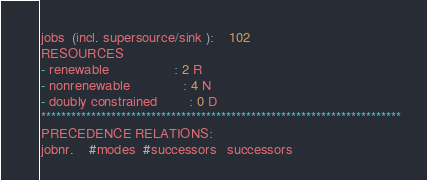<code> <loc_0><loc_0><loc_500><loc_500><_ObjectiveC_>jobs  (incl. supersource/sink ):	102
RESOURCES
- renewable                 : 2 R
- nonrenewable              : 4 N
- doubly constrained        : 0 D
************************************************************************
PRECEDENCE RELATIONS:
jobnr.    #modes  #successors   successors</code> 